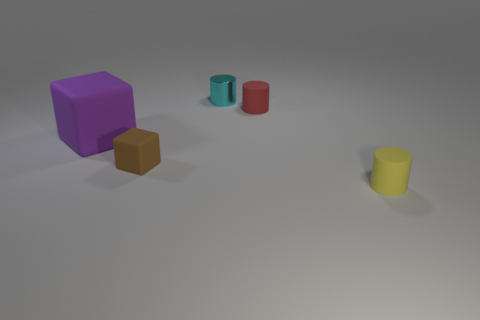Add 1 yellow things. How many objects exist? 6 Subtract all cylinders. How many objects are left? 2 Add 2 cubes. How many cubes are left? 4 Add 1 purple matte cubes. How many purple matte cubes exist? 2 Subtract 0 yellow balls. How many objects are left? 5 Subtract all big green cubes. Subtract all tiny red rubber cylinders. How many objects are left? 4 